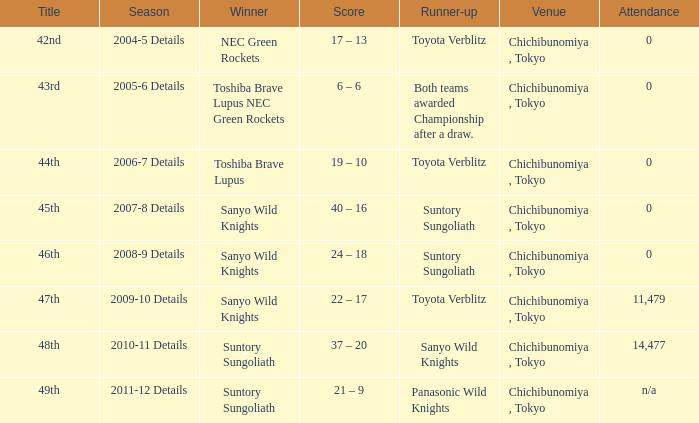What is the Attendance number for the title of 44th? 0.0. 